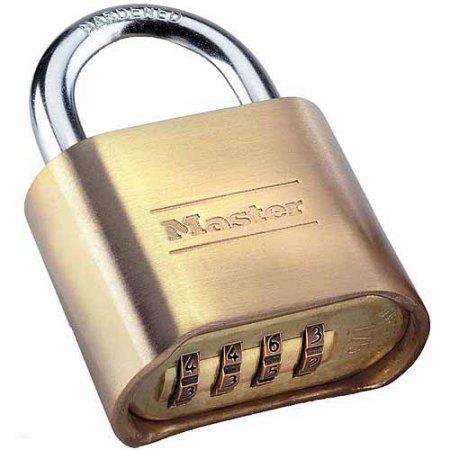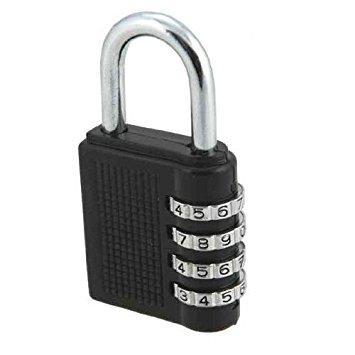The first image is the image on the left, the second image is the image on the right. Evaluate the accuracy of this statement regarding the images: "All locks are combination locks, with the number belts visible in the images.". Is it true? Answer yes or no. Yes. The first image is the image on the left, the second image is the image on the right. Considering the images on both sides, is "There are no less than two black padlocks" valid? Answer yes or no. No. 